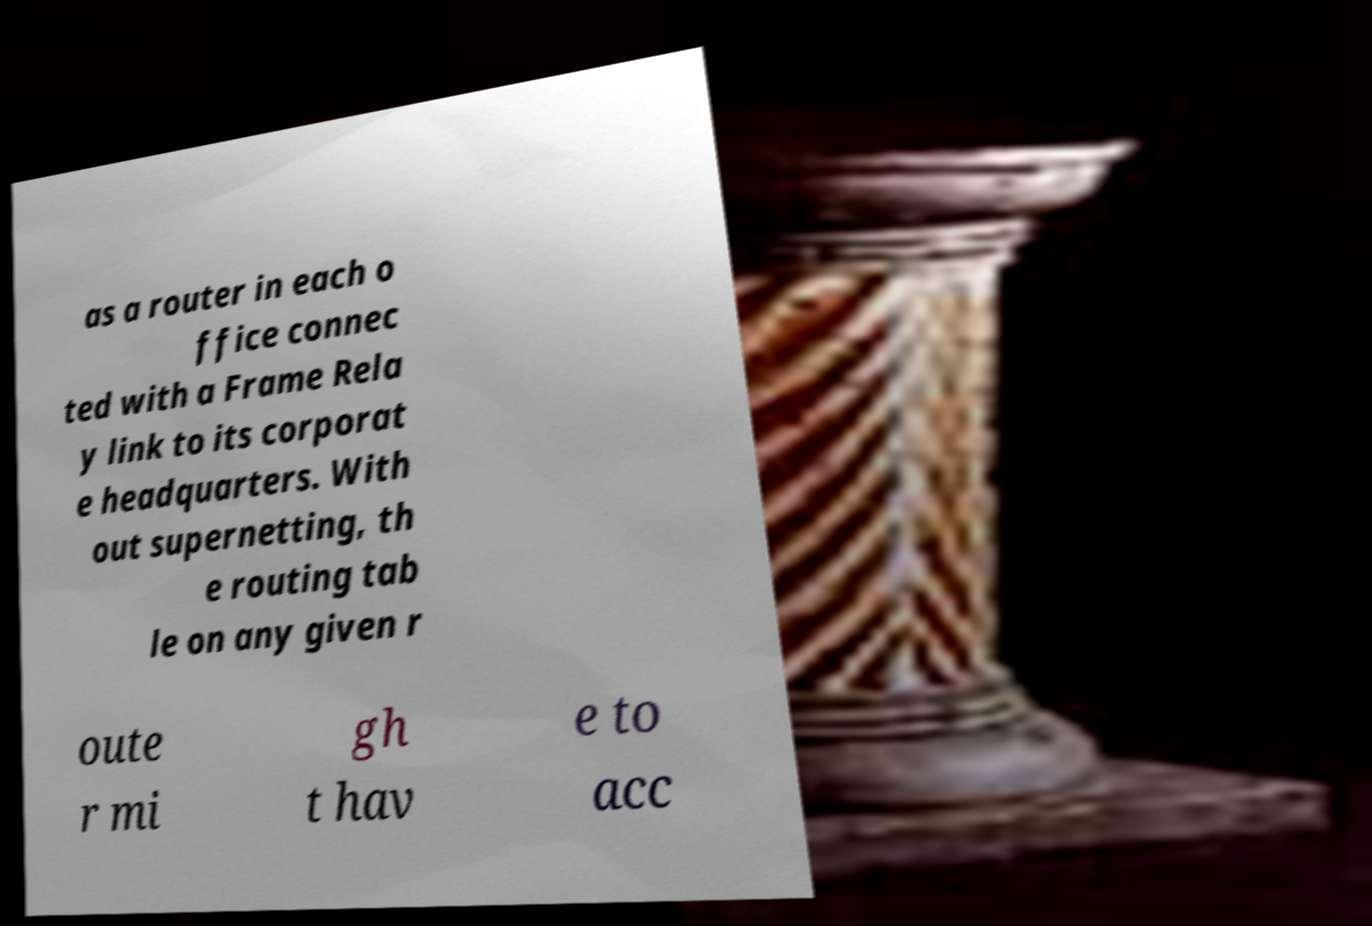Can you accurately transcribe the text from the provided image for me? as a router in each o ffice connec ted with a Frame Rela y link to its corporat e headquarters. With out supernetting, th e routing tab le on any given r oute r mi gh t hav e to acc 